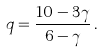Convert formula to latex. <formula><loc_0><loc_0><loc_500><loc_500>q = \frac { 1 0 - 3 \gamma } { 6 - \gamma } \, .</formula> 